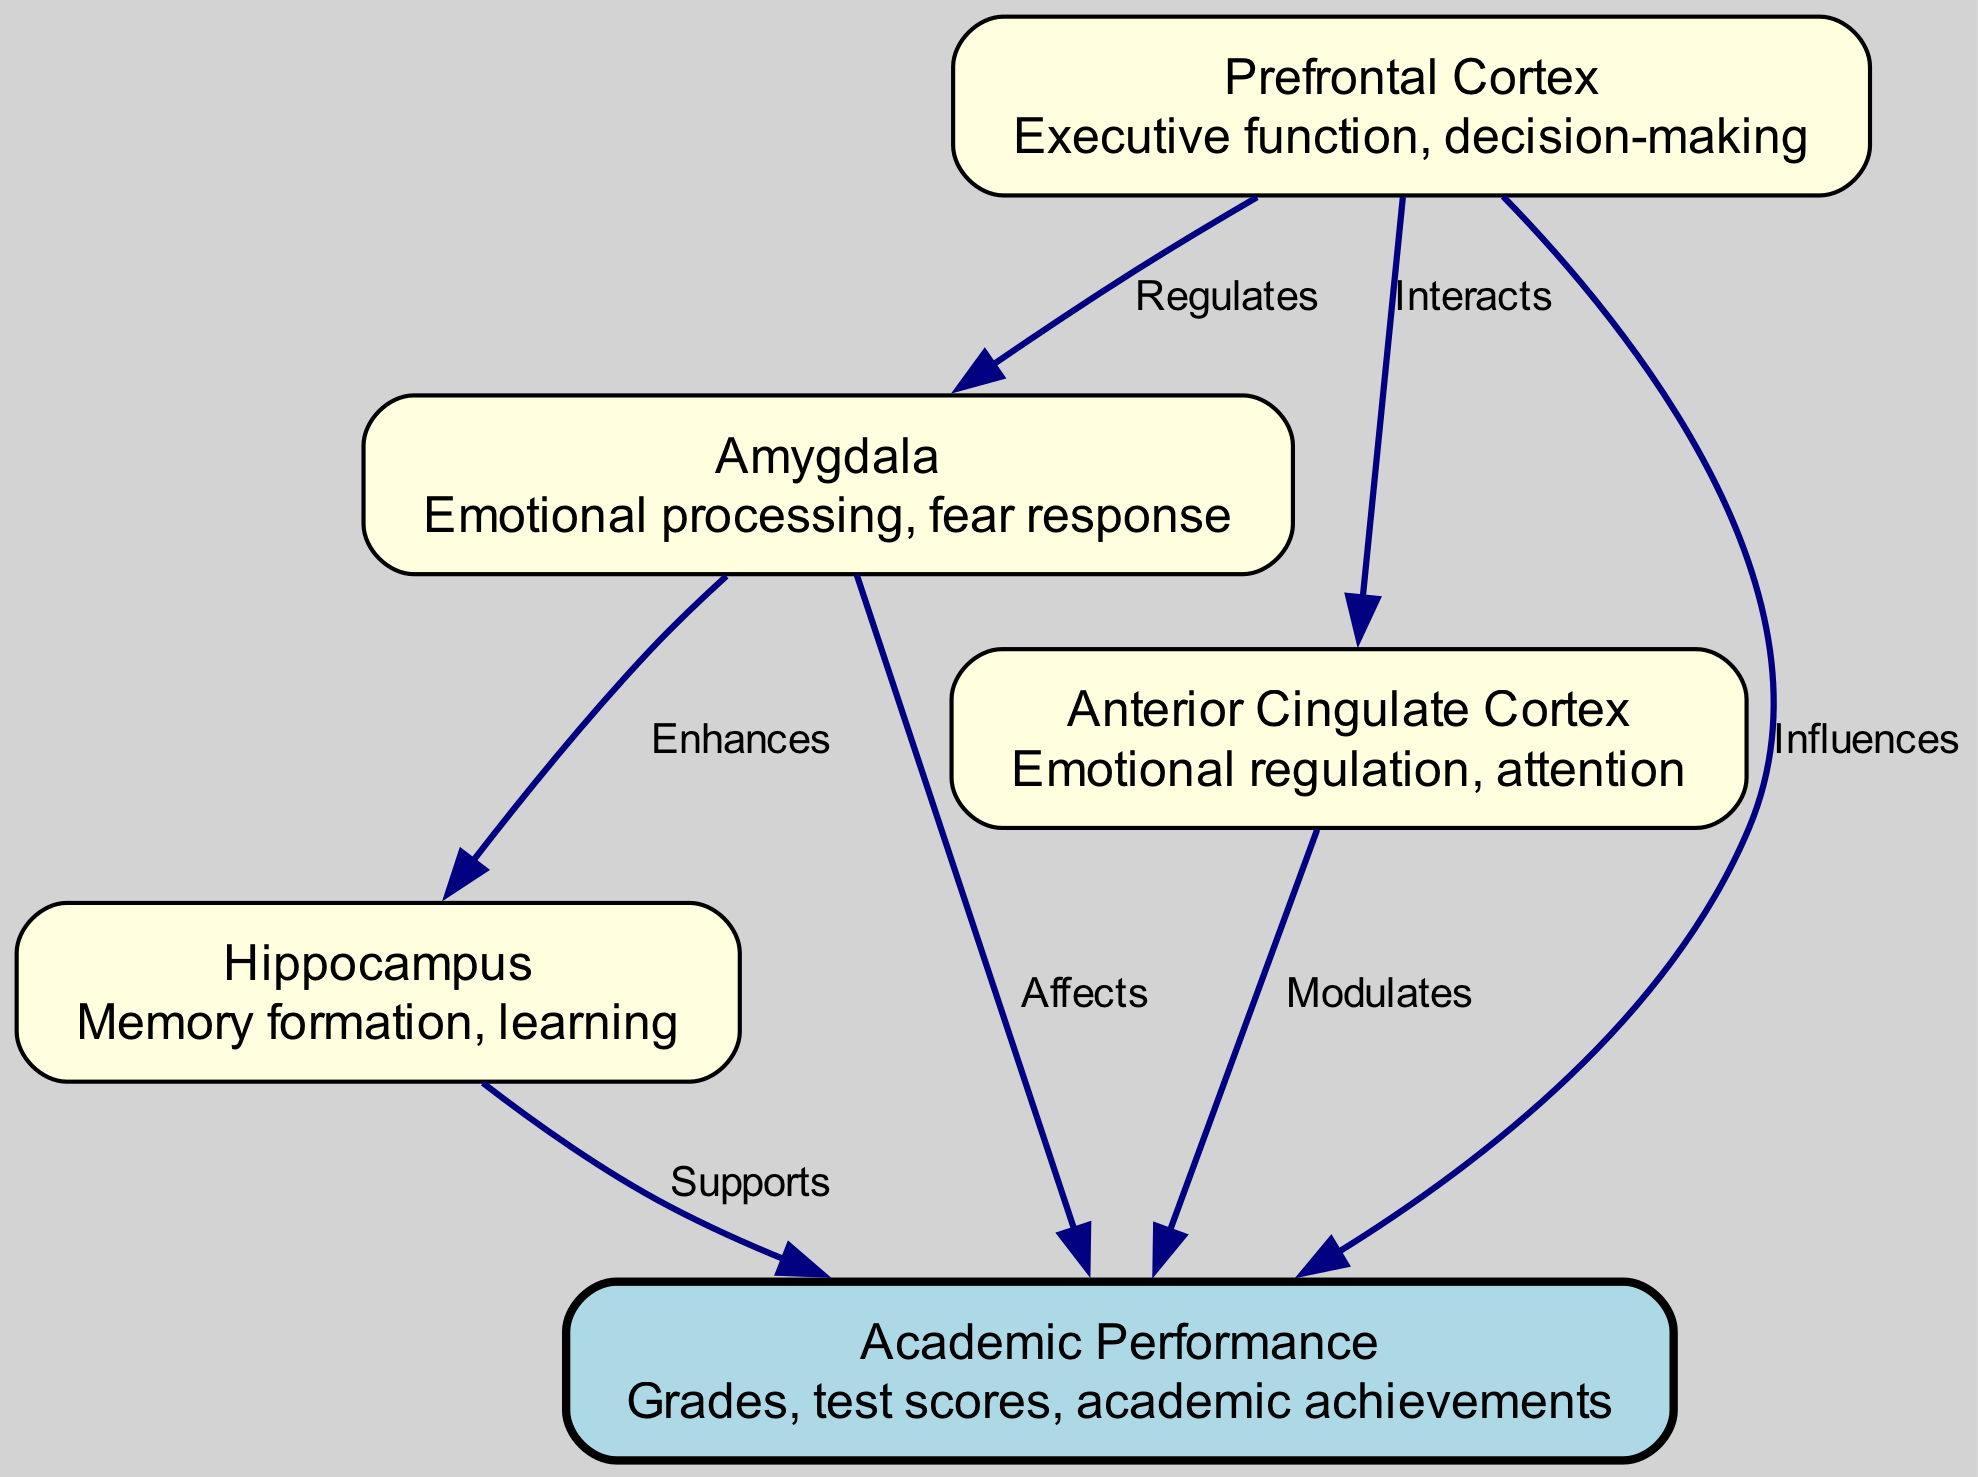What are the four brain regions identified in the diagram? The diagram displays four labeled brain regions: Prefrontal Cortex, Amygdala, Hippocampus, and Anterior Cingulate Cortex.
Answer: Prefrontal Cortex, Amygdala, Hippocampus, Anterior Cingulate Cortex How many edges connect the nodes to Academic Performance? The diagram shows four edges leading to the node representing Academic Performance, indicating how the brain regions influence academic achievement.
Answer: Four Which brain region is described as being involved in decision-making? The Prefrontal Cortex is specifically described in the diagram as being responsible for executive function and decision-making.
Answer: Prefrontal Cortex What type of relationship exists between the Amygdala and Academic Performance? The diagram indicates that the relationship between the Amygdala and Academic Performance is characterized by the label "Affects," highlighting its influence.
Answer: Affects Which brain region modulates attention according to the diagram? The Anterior Cingulate Cortex is identified in the diagram as modulating attention, which is crucial for learning and academic performance.
Answer: Anterior Cingulate Cortex Explain how the Prefrontal Cortex interacts with the other regions involved in emotional processing. The diagram outlines that the Prefrontal Cortex regulates the Amygdala and interacts with the Anterior Cingulate Cortex, signifying its role in overseeing emotional response and regulation, which are essential for cognitive functions and academic success.
Answer: Regulates, Interacts Which brain region is primarily associated with memory formation? According to the diagram, the Hippocampus is highlighted as the region associated with memory formation and learning processes.
Answer: Hippocampus How does the Amygdala enhance the functionality of the Hippocampus? The diagram illustrates an "Enhances" label showing that the Amygdala enhances the capabilities of the Hippocampus, indicating a supportive role in emotional memory and learning acquisition.
Answer: Enhances What is the primary focus of Academic Performance in the context of this diagram? Academic Performance is mainly focused on grades, test scores, and overall academic achievements as described in the diagram.
Answer: Grades, test scores, academic achievements 